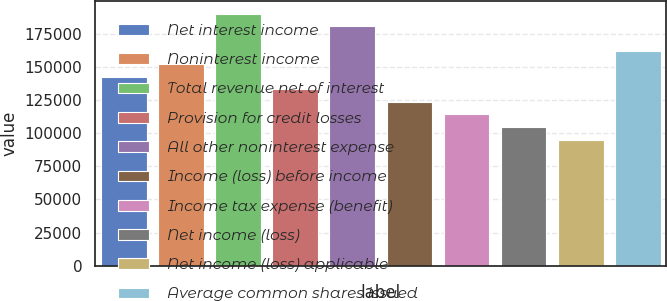Convert chart. <chart><loc_0><loc_0><loc_500><loc_500><bar_chart><fcel>Net interest income<fcel>Noninterest income<fcel>Total revenue net of interest<fcel>Provision for credit losses<fcel>All other noninterest expense<fcel>Income (loss) before income<fcel>Income tax expense (benefit)<fcel>Net income (loss)<fcel>Net income (loss) applicable<fcel>Average common shares issued<nl><fcel>142745<fcel>152261<fcel>190326<fcel>133228<fcel>180810<fcel>123712<fcel>114196<fcel>104679<fcel>95163<fcel>161777<nl></chart> 